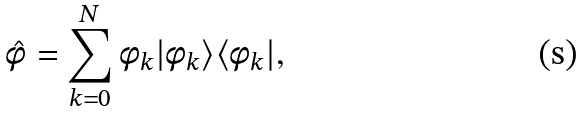<formula> <loc_0><loc_0><loc_500><loc_500>\hat { \phi } = \sum _ { k = 0 } ^ { N } \phi _ { k } | \phi _ { k } \rangle \langle \phi _ { k } | ,</formula> 